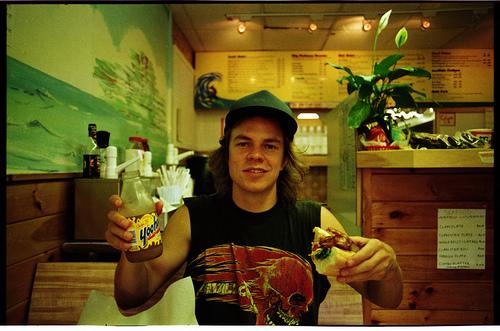What is hanging on the wall in the background? A long menu, a piece of hand-written paper, and a mural depicting the ocean. What are the two main items in the man's hands? A bottle of Yoohoo and a sandwich. What kind of headdress is the man wearing? The man is wearing a green baseball cap. Identify the type of establishment where the man is located. This is a restaurant. Describe the type of food the man is holding. A sandwich with sauce on it. Estimate the emotion of the man in the image. The man is smiling, implying he is happy or content. What is the subject of the interaction in the image? Man holding a Yoohoo bottle and sandwich in his hands. Can you describe the man's shirt in more detail? The shirt is black, sleeveless, and with a red skull print on it. How many lights are there on the ceiling? There is a line of four lights on the ceiling. List the primary colors of the man's clothing and hat. Green hat, black tank top with red skull design. Can you find a cup with only one straw in it? There is no cup with only one straw. The cup in the image has a lot of straws. Could you point out the man wearing a yellow hat? There is no man wearing a yellow hat in the image. The man is wearing a green hat. Could you point out the wall painted like a forest? There is no wall painted like a forest. The wall in the image is painted like an ocean. Where is the cat in the image? There is no cat in the image, so this question would confuse someone looking for it. Do you see a man wearing a blue tank top? There is no man wearing a blue tank top in the image. The tank top is black. Can you find a sandwich without any sauce on it? There is no sandwich without sauce in the image. The sandwich in the image has sauce on it. 